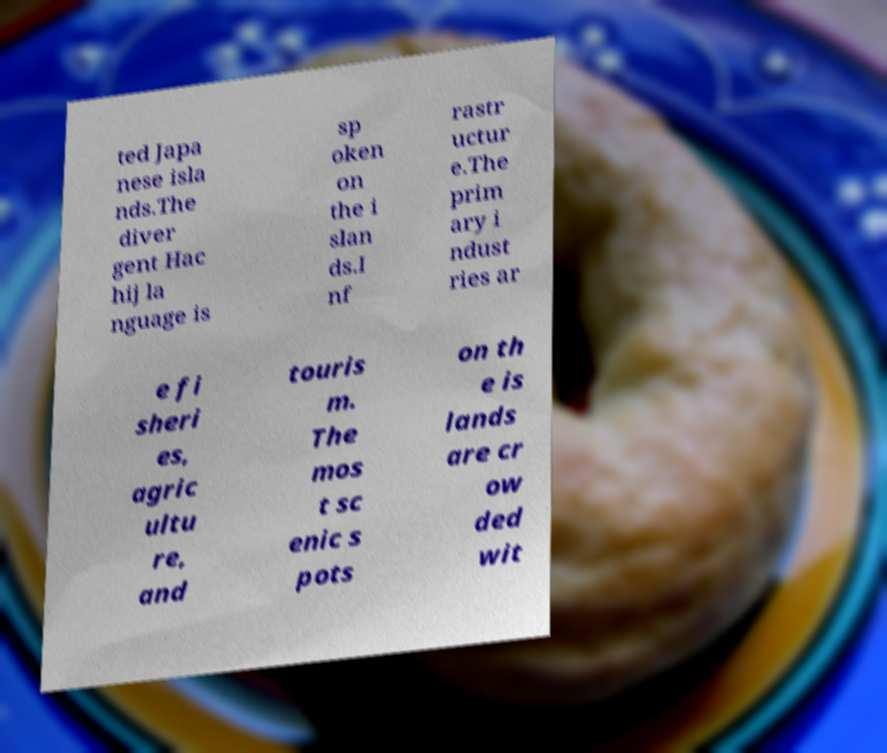Please identify and transcribe the text found in this image. ted Japa nese isla nds.The diver gent Hac hij la nguage is sp oken on the i slan ds.I nf rastr uctur e.The prim ary i ndust ries ar e fi sheri es, agric ultu re, and touris m. The mos t sc enic s pots on th e is lands are cr ow ded wit 